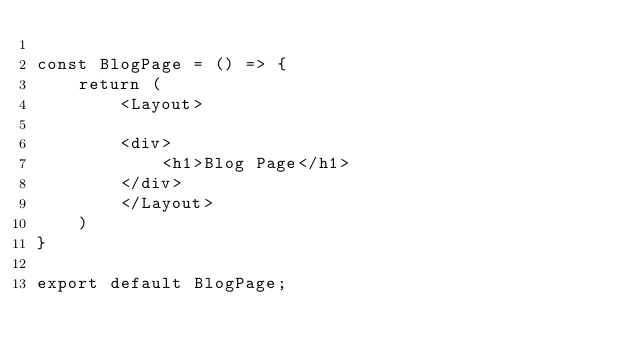Convert code to text. <code><loc_0><loc_0><loc_500><loc_500><_JavaScript_>
const BlogPage = () => {
    return (
        <Layout>

        <div>
            <h1>Blog Page</h1>
        </div>
        </Layout>
    )
}

export default BlogPage;</code> 